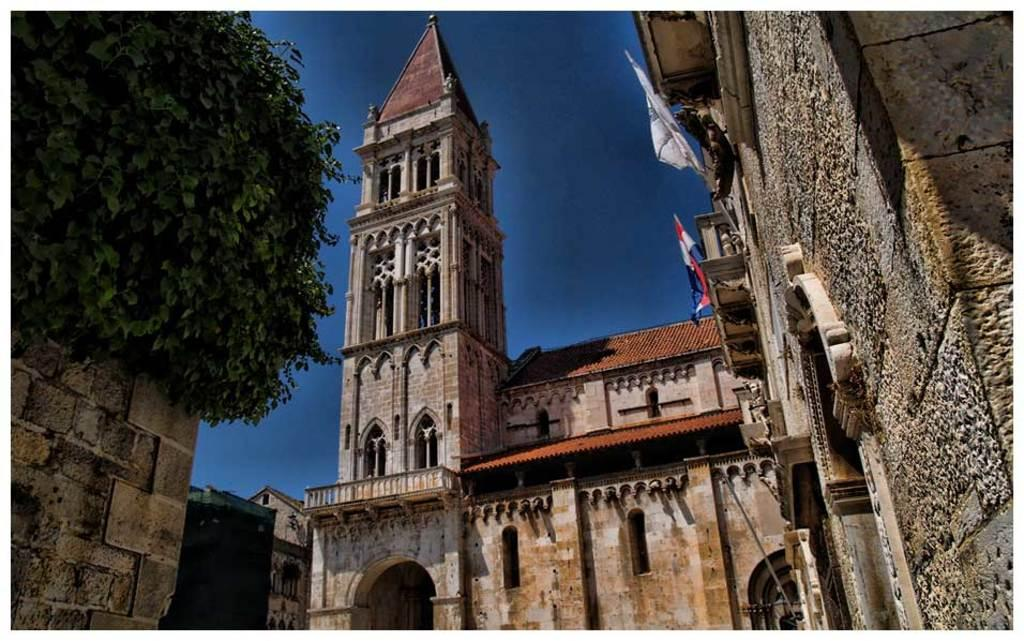What type of structures can be seen in the image? There are buildings in the image. Where is the tree located in the image? The tree is on the left side of the image. What decorative elements are present on one of the buildings? There are flags on one of the buildings. What part of the natural environment is visible in the image? The sky is visible in the image. What is the color of the green object in the image? The green object in the image is green. What type of holiday is being celebrated by the sack in the image? There is no sack present in the image, so it cannot be determined if a holiday is being celebrated. 